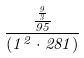<formula> <loc_0><loc_0><loc_500><loc_500>\frac { \frac { \frac { 9 } { 3 } } { 9 5 } } { ( 1 ^ { 2 } \cdot 2 8 1 ) }</formula> 